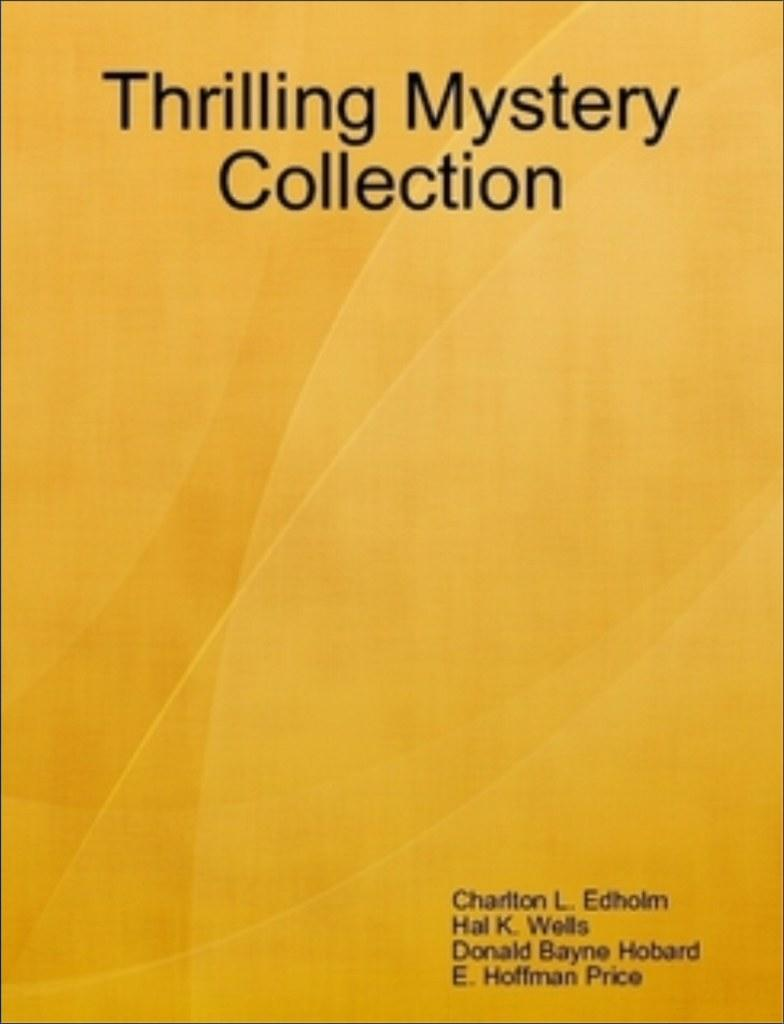Provide a one-sentence caption for the provided image. the title of the book is 'Thrilling Mystery Collection'. 